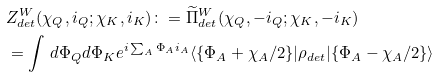Convert formula to latex. <formula><loc_0><loc_0><loc_500><loc_500>& Z ^ { W } _ { d e t } ( \chi _ { Q } , i _ { Q } ; \chi _ { K } , i _ { K } ) \colon = \widetilde { \Pi } ^ { W } _ { d e t } ( \chi _ { Q } , - i _ { Q } ; \chi _ { K } , - i _ { K } ) \\ & = \int \, d \Phi _ { Q } d \Phi _ { K } e ^ { i \sum _ { A } \Phi _ { A } i _ { A } } \langle \{ \Phi _ { A } + \chi _ { A } / 2 \} | \rho _ { d e t } | \{ \Phi _ { A } - \chi _ { A } / 2 \} \rangle</formula> 